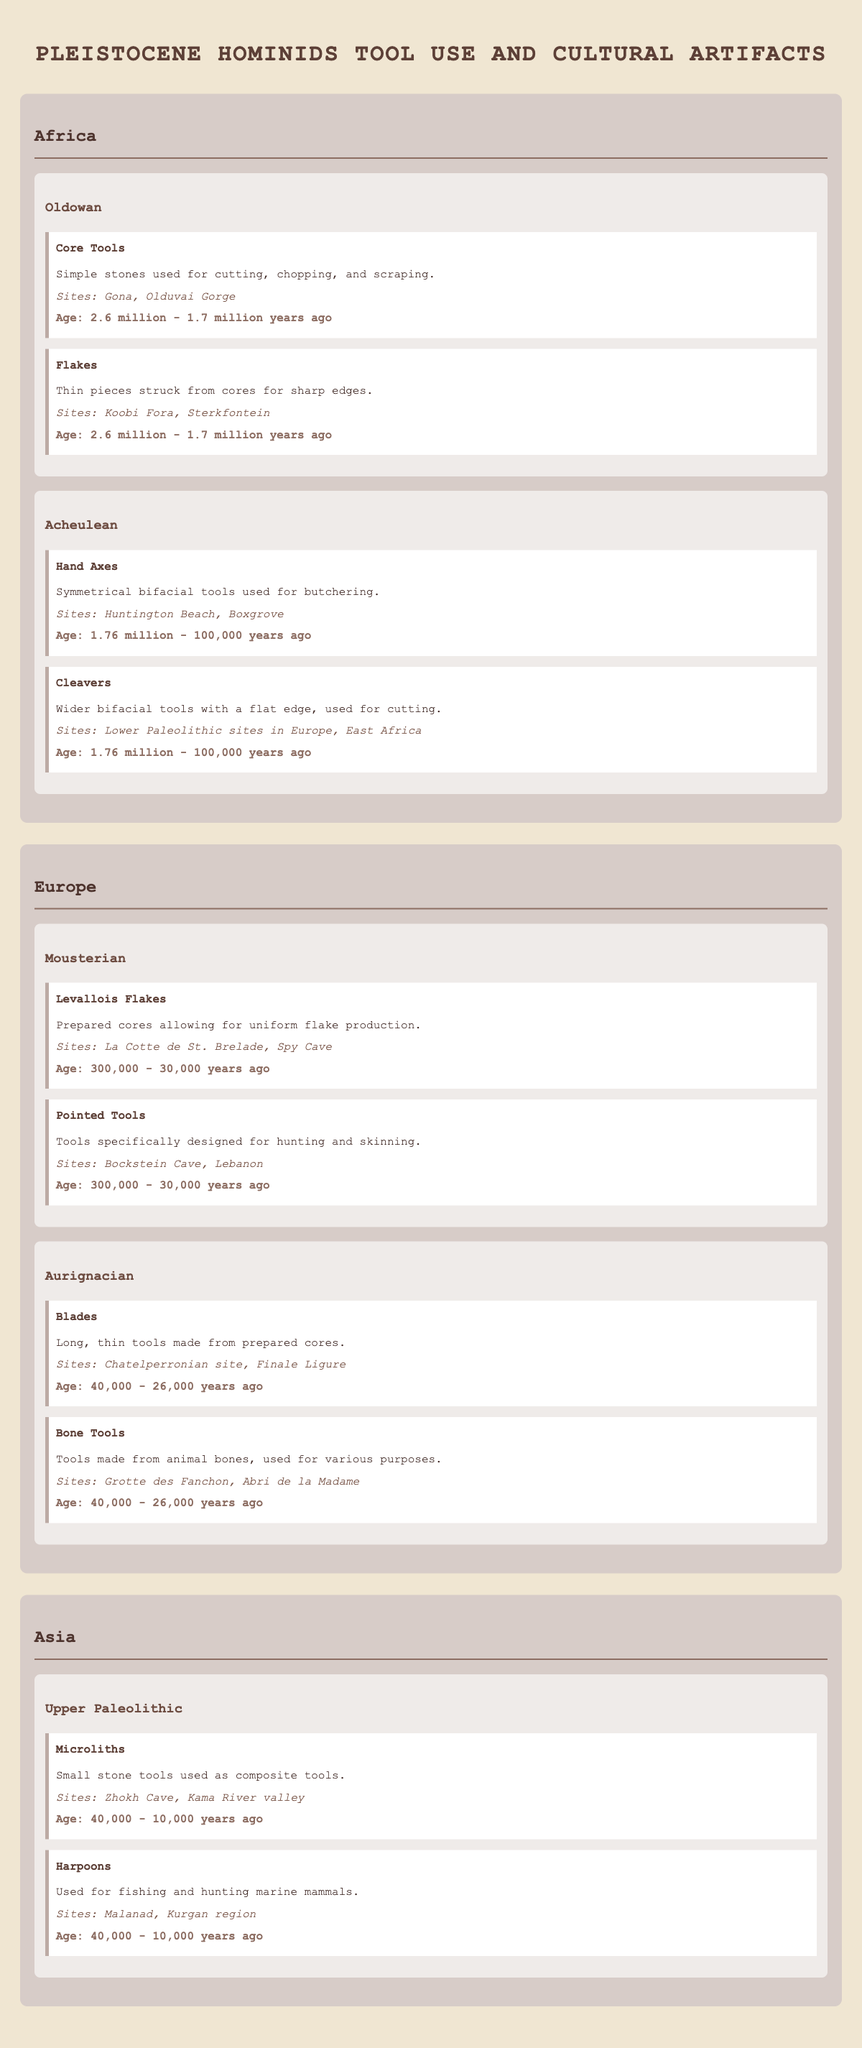What artifacts belong to the Oldowan tool type in Africa? The Oldowan tool type in Africa includes “Core Tools,” which are simple stones used for cutting, chopping, and scraping, and “Flakes,” which are thin pieces struck from cores for sharp edges.
Answer: Core Tools and Flakes What is the approximate age range for Acheulean tools found in Africa? The Acheulean tools found in Africa are dated approximately from 1.76 million to 100,000 years ago as listed in the artifact descriptions.
Answer: 1.76 million - 100,000 years ago Did the Mousterian tool type include tools designed specifically for hunting? Yes, the Mousterian tool type included “Pointed Tools,” which are specifically designed for hunting and skinning.
Answer: Yes How many unique sites are mentioned for the Aurignacian tools in Europe? The Aurignacian tools mention two unique sites: "Chatelperronian site" and "Finale Ligure" for Blades and "Grotte des Fanchon" and "Abri de la Madame" for Bone Tools. Therefore, there are four unique sites.
Answer: 4 Which regions display evidence of the Upper Paleolithic tools? The Upper Paleolithic tools are specifically cited in the region of Asia, with no mention of them in Africa or Europe.
Answer: Asia What is the average age range of tools found in the African region? The Oldowan tools range from 2.6 million to 1.7 million years ago and the Acheulean tools range from 1.76 million to 100,000 years ago. To find the average: convert the ranges into a single number; for Oldowan, it's (2.6M + 1.7M) / 2 = 2.15M and for Acheulean, it's (1.76M + 0.1M) / 2 = 0.93M. The average of these two averages, (2.15M + 0.93M) / 2 = 1.04M years ago.
Answer: 1.04 million years ago 